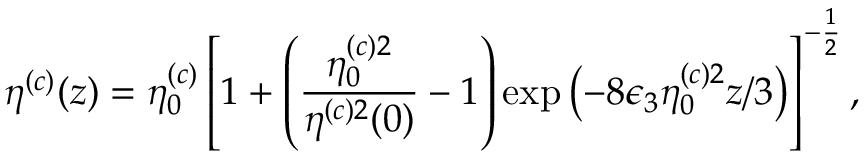Convert formula to latex. <formula><loc_0><loc_0><loc_500><loc_500>\eta ^ { ( c ) } ( z ) = \eta _ { 0 } ^ { ( c ) } \left [ 1 + \left ( \frac { \eta _ { 0 } ^ { ( c ) 2 } } { \eta ^ { ( c ) 2 } ( 0 ) } - 1 \right ) \exp \left ( - 8 \epsilon _ { 3 } \eta _ { 0 } ^ { ( c ) 2 } z / 3 \right ) \right ] ^ { - \frac { 1 } { 2 } } ,</formula> 